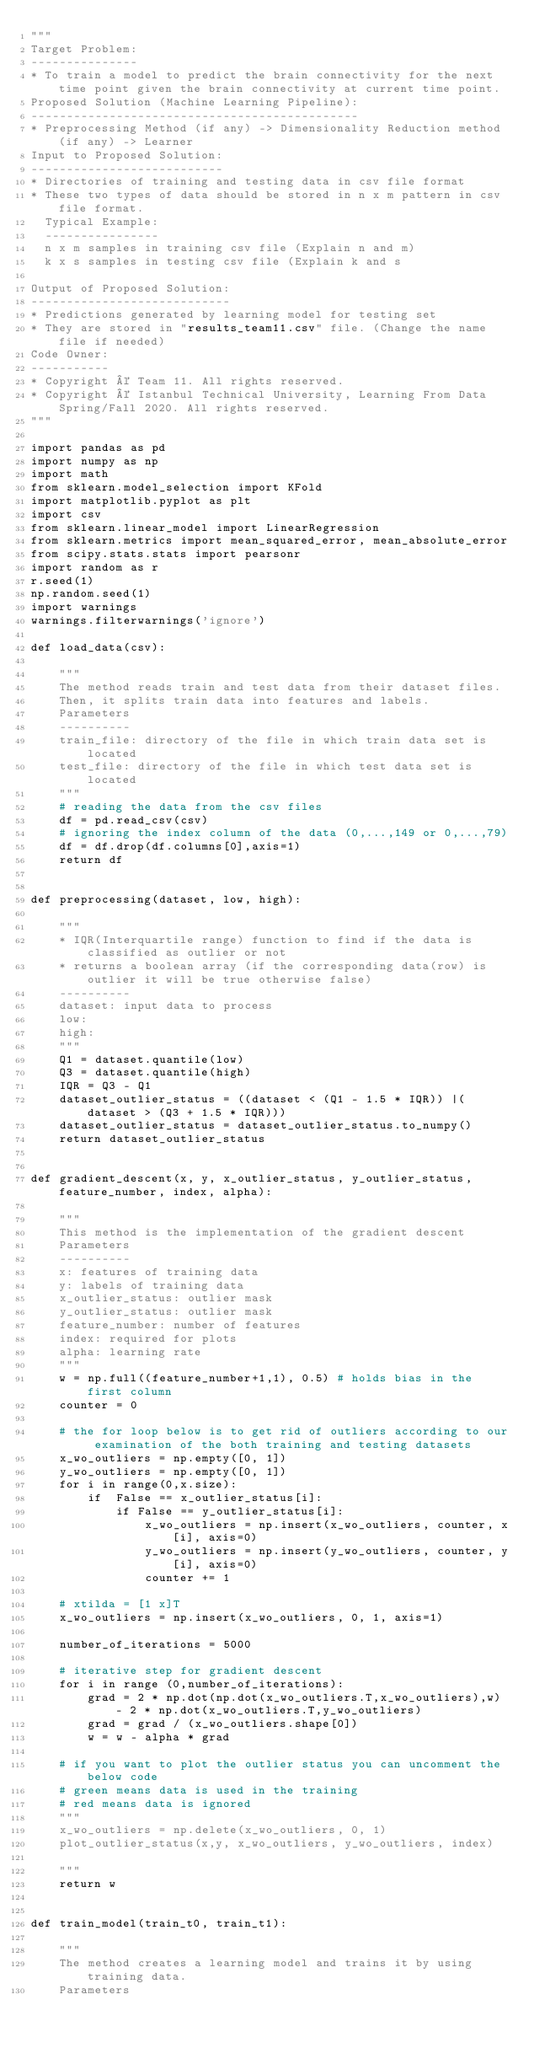<code> <loc_0><loc_0><loc_500><loc_500><_Python_>"""
Target Problem:
---------------
* To train a model to predict the brain connectivity for the next time point given the brain connectivity at current time point.
Proposed Solution (Machine Learning Pipeline):
----------------------------------------------
* Preprocessing Method (if any) -> Dimensionality Reduction method (if any) -> Learner
Input to Proposed Solution:
---------------------------
* Directories of training and testing data in csv file format
* These two types of data should be stored in n x m pattern in csv file format.
  Typical Example:
  ----------------
  n x m samples in training csv file (Explain n and m) 
  k x s samples in testing csv file (Explain k and s

Output of Proposed Solution:
----------------------------
* Predictions generated by learning model for testing set
* They are stored in "results_team11.csv" file. (Change the name file if needed)
Code Owner:
-----------
* Copyright © Team 11. All rights reserved.
* Copyright © Istanbul Technical University, Learning From Data Spring/Fall 2020. All rights reserved. 
"""

import pandas as pd
import numpy as np
import math 
from sklearn.model_selection import KFold
import matplotlib.pyplot as plt
import csv
from sklearn.linear_model import LinearRegression
from sklearn.metrics import mean_squared_error, mean_absolute_error
from scipy.stats.stats import pearsonr
import random as r
r.seed(1)
np.random.seed(1)
import warnings
warnings.filterwarnings('ignore')

def load_data(csv):

    """
    The method reads train and test data from their dataset files.
    Then, it splits train data into features and labels.
    Parameters
    ----------
    train_file: directory of the file in which train data set is located
    test_file: directory of the file in which test data set is located
    """
    # reading the data from the csv files
    df = pd.read_csv(csv)
    # ignoring the index column of the data (0,...,149 or 0,...,79)
    df = df.drop(df.columns[0],axis=1)
    return df


def preprocessing(dataset, low, high):
 
    """
    * IQR(Interquartile range) function to find if the data is classified as outlier or not
    * returns a boolean array (if the corresponding data(row) is outlier it will be true otherwise false)
    ----------
    dataset: input data to process
    low: 
    high:
    """
    Q1 = dataset.quantile(low)
    Q3 = dataset.quantile(high)
    IQR = Q3 - Q1
    dataset_outlier_status = ((dataset < (Q1 - 1.5 * IQR)) |(dataset > (Q3 + 1.5 * IQR)))
    dataset_outlier_status = dataset_outlier_status.to_numpy()
    return dataset_outlier_status


def gradient_descent(x, y, x_outlier_status, y_outlier_status, feature_number, index, alpha):

    """
    This method is the implementation of the gradient descent
    Parameters
    ----------
    x: features of training data
    y: labels of training data
    x_outlier_status: outlier mask
    y_outlier_status: outlier mask
    feature_number: number of features
    index: required for plots
    alpha: learning rate
    """
    w = np.full((feature_number+1,1), 0.5) # holds bias in the first column
    counter = 0
    
    # the for loop below is to get rid of outliers according to our examination of the both training and testing datasets
    x_wo_outliers = np.empty([0, 1])
    y_wo_outliers = np.empty([0, 1])
    for i in range(0,x.size):
        if  False == x_outlier_status[i]:
            if False == y_outlier_status[i]:
                x_wo_outliers = np.insert(x_wo_outliers, counter, x[i], axis=0)
                y_wo_outliers = np.insert(y_wo_outliers, counter, y[i], axis=0)
                counter += 1
    
    # xtilda = [1 x]T
    x_wo_outliers = np.insert(x_wo_outliers, 0, 1, axis=1)
    
    number_of_iterations = 5000
    
    # iterative step for gradient descent
    for i in range (0,number_of_iterations):
        grad = 2 * np.dot(np.dot(x_wo_outliers.T,x_wo_outliers),w) - 2 * np.dot(x_wo_outliers.T,y_wo_outliers)
        grad = grad / (x_wo_outliers.shape[0])
        w = w - alpha * grad
    
    # if you want to plot the outlier status you can uncomment the below code
    # green means data is used in the training
    # red means data is ignored
    """
    x_wo_outliers = np.delete(x_wo_outliers, 0, 1)
    plot_outlier_status(x,y, x_wo_outliers, y_wo_outliers, index)
    
    """
    return w


def train_model(train_t0, train_t1):

    """
    The method creates a learning model and trains it by using training data.
    Parameters</code> 